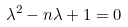<formula> <loc_0><loc_0><loc_500><loc_500>\lambda ^ { 2 } - n \lambda + 1 = 0</formula> 